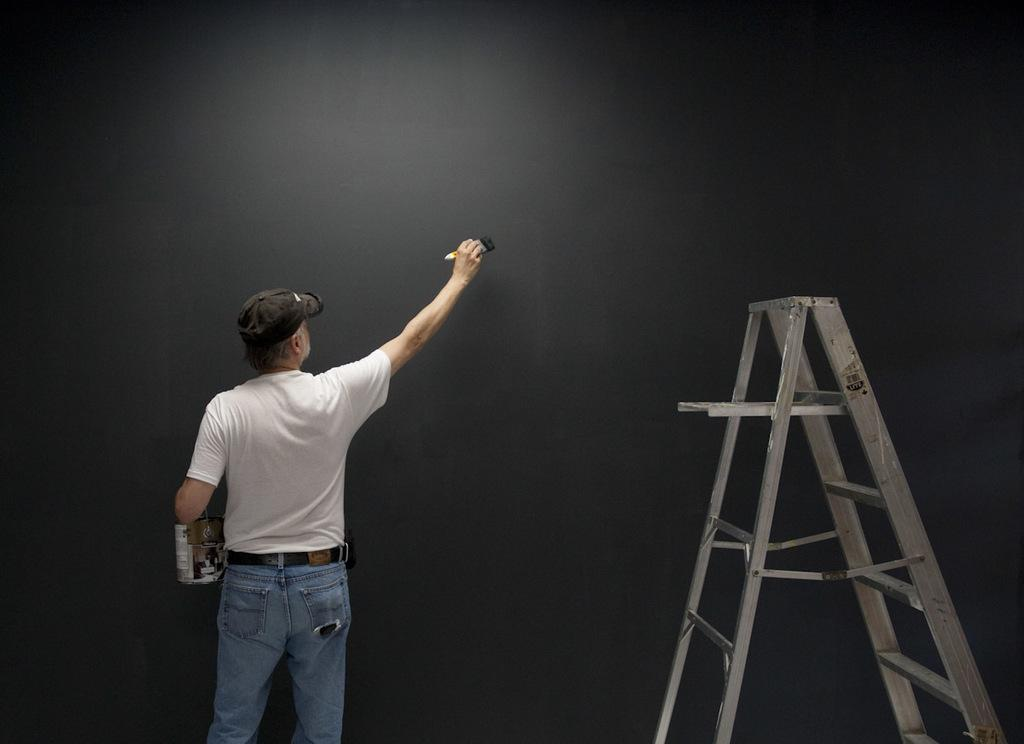What is the person holding in their hand in the image? The person is holding a paint bottle and a paint brush in their hand. What is the person facing in the image? The person is facing a black wall in the image. What might the person be using to reach a higher point on the wall? There is a step ladder stool in the image, which the person might be using to reach a higher point on the wall. What type of riddle is the person trying to solve while standing on the step ladder stool? There is no riddle present in the image, and the person is not trying to solve a riddle while standing on the step ladder stool. Can you see a lamp in the image? There is no lamp visible in the image; the focus is on the person, their painting tools, and the black wall. 